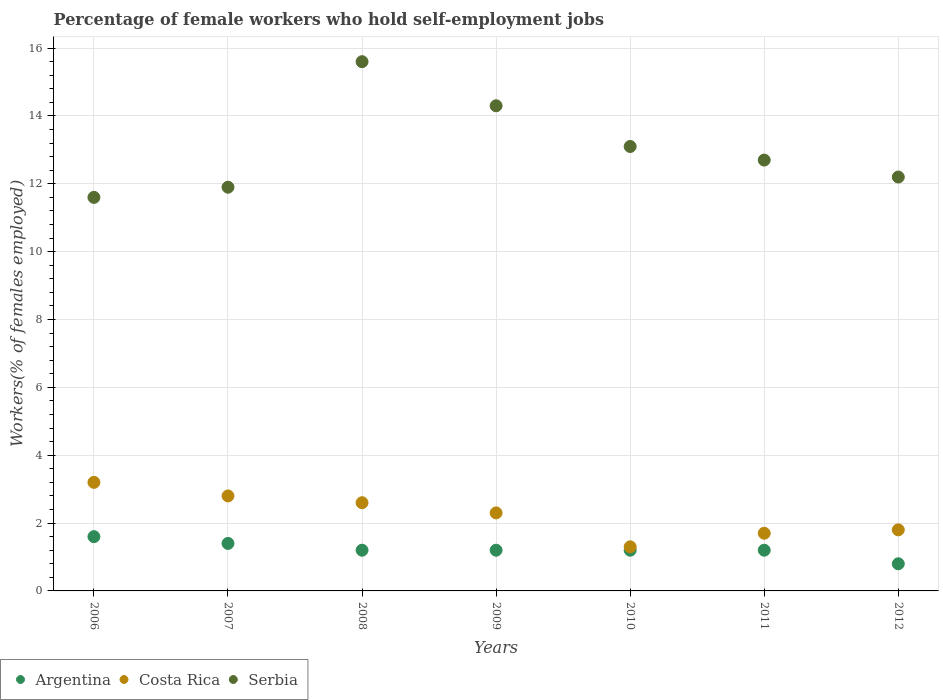What is the percentage of self-employed female workers in Argentina in 2006?
Offer a very short reply. 1.6. Across all years, what is the maximum percentage of self-employed female workers in Serbia?
Provide a short and direct response. 15.6. Across all years, what is the minimum percentage of self-employed female workers in Serbia?
Give a very brief answer. 11.6. What is the total percentage of self-employed female workers in Argentina in the graph?
Your answer should be compact. 8.6. What is the difference between the percentage of self-employed female workers in Costa Rica in 2007 and that in 2008?
Offer a terse response. 0.2. What is the difference between the percentage of self-employed female workers in Argentina in 2007 and the percentage of self-employed female workers in Costa Rica in 2012?
Give a very brief answer. -0.4. What is the average percentage of self-employed female workers in Serbia per year?
Give a very brief answer. 13.06. In the year 2011, what is the difference between the percentage of self-employed female workers in Serbia and percentage of self-employed female workers in Argentina?
Offer a very short reply. 11.5. What is the difference between the highest and the second highest percentage of self-employed female workers in Argentina?
Make the answer very short. 0.2. What is the difference between the highest and the lowest percentage of self-employed female workers in Argentina?
Provide a succinct answer. 0.8. In how many years, is the percentage of self-employed female workers in Serbia greater than the average percentage of self-employed female workers in Serbia taken over all years?
Offer a very short reply. 3. Is the sum of the percentage of self-employed female workers in Costa Rica in 2010 and 2012 greater than the maximum percentage of self-employed female workers in Argentina across all years?
Provide a short and direct response. Yes. Is it the case that in every year, the sum of the percentage of self-employed female workers in Serbia and percentage of self-employed female workers in Costa Rica  is greater than the percentage of self-employed female workers in Argentina?
Provide a short and direct response. Yes. Is the percentage of self-employed female workers in Costa Rica strictly greater than the percentage of self-employed female workers in Argentina over the years?
Your answer should be very brief. Yes. Is the percentage of self-employed female workers in Serbia strictly less than the percentage of self-employed female workers in Argentina over the years?
Your answer should be very brief. No. Does the graph contain grids?
Your response must be concise. Yes. Where does the legend appear in the graph?
Keep it short and to the point. Bottom left. How are the legend labels stacked?
Offer a very short reply. Horizontal. What is the title of the graph?
Offer a very short reply. Percentage of female workers who hold self-employment jobs. What is the label or title of the Y-axis?
Make the answer very short. Workers(% of females employed). What is the Workers(% of females employed) of Argentina in 2006?
Make the answer very short. 1.6. What is the Workers(% of females employed) in Costa Rica in 2006?
Your answer should be very brief. 3.2. What is the Workers(% of females employed) of Serbia in 2006?
Keep it short and to the point. 11.6. What is the Workers(% of females employed) in Argentina in 2007?
Provide a short and direct response. 1.4. What is the Workers(% of females employed) of Costa Rica in 2007?
Your answer should be compact. 2.8. What is the Workers(% of females employed) in Serbia in 2007?
Your answer should be very brief. 11.9. What is the Workers(% of females employed) in Argentina in 2008?
Provide a succinct answer. 1.2. What is the Workers(% of females employed) in Costa Rica in 2008?
Offer a very short reply. 2.6. What is the Workers(% of females employed) in Serbia in 2008?
Offer a terse response. 15.6. What is the Workers(% of females employed) in Argentina in 2009?
Make the answer very short. 1.2. What is the Workers(% of females employed) in Costa Rica in 2009?
Your answer should be very brief. 2.3. What is the Workers(% of females employed) in Serbia in 2009?
Provide a succinct answer. 14.3. What is the Workers(% of females employed) of Argentina in 2010?
Ensure brevity in your answer.  1.2. What is the Workers(% of females employed) in Costa Rica in 2010?
Ensure brevity in your answer.  1.3. What is the Workers(% of females employed) in Serbia in 2010?
Provide a short and direct response. 13.1. What is the Workers(% of females employed) of Argentina in 2011?
Your answer should be compact. 1.2. What is the Workers(% of females employed) of Costa Rica in 2011?
Make the answer very short. 1.7. What is the Workers(% of females employed) in Serbia in 2011?
Ensure brevity in your answer.  12.7. What is the Workers(% of females employed) of Argentina in 2012?
Provide a succinct answer. 0.8. What is the Workers(% of females employed) of Costa Rica in 2012?
Your answer should be very brief. 1.8. What is the Workers(% of females employed) of Serbia in 2012?
Ensure brevity in your answer.  12.2. Across all years, what is the maximum Workers(% of females employed) of Argentina?
Make the answer very short. 1.6. Across all years, what is the maximum Workers(% of females employed) in Costa Rica?
Your answer should be very brief. 3.2. Across all years, what is the maximum Workers(% of females employed) of Serbia?
Your answer should be compact. 15.6. Across all years, what is the minimum Workers(% of females employed) of Argentina?
Your answer should be compact. 0.8. Across all years, what is the minimum Workers(% of females employed) of Costa Rica?
Keep it short and to the point. 1.3. Across all years, what is the minimum Workers(% of females employed) in Serbia?
Keep it short and to the point. 11.6. What is the total Workers(% of females employed) in Argentina in the graph?
Offer a terse response. 8.6. What is the total Workers(% of females employed) of Costa Rica in the graph?
Your response must be concise. 15.7. What is the total Workers(% of females employed) in Serbia in the graph?
Your response must be concise. 91.4. What is the difference between the Workers(% of females employed) in Argentina in 2006 and that in 2007?
Keep it short and to the point. 0.2. What is the difference between the Workers(% of females employed) in Costa Rica in 2006 and that in 2008?
Provide a succinct answer. 0.6. What is the difference between the Workers(% of females employed) in Argentina in 2006 and that in 2009?
Ensure brevity in your answer.  0.4. What is the difference between the Workers(% of females employed) in Costa Rica in 2006 and that in 2009?
Your response must be concise. 0.9. What is the difference between the Workers(% of females employed) in Argentina in 2006 and that in 2010?
Your answer should be very brief. 0.4. What is the difference between the Workers(% of females employed) of Serbia in 2006 and that in 2010?
Give a very brief answer. -1.5. What is the difference between the Workers(% of females employed) in Costa Rica in 2006 and that in 2011?
Provide a succinct answer. 1.5. What is the difference between the Workers(% of females employed) of Costa Rica in 2006 and that in 2012?
Your answer should be very brief. 1.4. What is the difference between the Workers(% of females employed) in Costa Rica in 2007 and that in 2008?
Make the answer very short. 0.2. What is the difference between the Workers(% of females employed) of Costa Rica in 2007 and that in 2009?
Ensure brevity in your answer.  0.5. What is the difference between the Workers(% of females employed) in Serbia in 2007 and that in 2009?
Offer a terse response. -2.4. What is the difference between the Workers(% of females employed) in Argentina in 2007 and that in 2010?
Your response must be concise. 0.2. What is the difference between the Workers(% of females employed) of Serbia in 2007 and that in 2010?
Ensure brevity in your answer.  -1.2. What is the difference between the Workers(% of females employed) of Argentina in 2007 and that in 2011?
Make the answer very short. 0.2. What is the difference between the Workers(% of females employed) of Serbia in 2007 and that in 2011?
Your answer should be very brief. -0.8. What is the difference between the Workers(% of females employed) of Costa Rica in 2007 and that in 2012?
Provide a short and direct response. 1. What is the difference between the Workers(% of females employed) in Serbia in 2007 and that in 2012?
Your answer should be very brief. -0.3. What is the difference between the Workers(% of females employed) of Costa Rica in 2008 and that in 2009?
Ensure brevity in your answer.  0.3. What is the difference between the Workers(% of females employed) in Serbia in 2008 and that in 2010?
Your response must be concise. 2.5. What is the difference between the Workers(% of females employed) of Argentina in 2008 and that in 2011?
Give a very brief answer. 0. What is the difference between the Workers(% of females employed) in Serbia in 2008 and that in 2011?
Give a very brief answer. 2.9. What is the difference between the Workers(% of females employed) in Argentina in 2008 and that in 2012?
Provide a succinct answer. 0.4. What is the difference between the Workers(% of females employed) in Costa Rica in 2008 and that in 2012?
Give a very brief answer. 0.8. What is the difference between the Workers(% of females employed) in Serbia in 2008 and that in 2012?
Your response must be concise. 3.4. What is the difference between the Workers(% of females employed) of Argentina in 2009 and that in 2010?
Offer a terse response. 0. What is the difference between the Workers(% of females employed) of Costa Rica in 2009 and that in 2010?
Make the answer very short. 1. What is the difference between the Workers(% of females employed) in Serbia in 2009 and that in 2010?
Offer a very short reply. 1.2. What is the difference between the Workers(% of females employed) of Argentina in 2009 and that in 2011?
Provide a short and direct response. 0. What is the difference between the Workers(% of females employed) in Serbia in 2009 and that in 2011?
Your response must be concise. 1.6. What is the difference between the Workers(% of females employed) in Argentina in 2009 and that in 2012?
Provide a succinct answer. 0.4. What is the difference between the Workers(% of females employed) in Serbia in 2010 and that in 2012?
Provide a succinct answer. 0.9. What is the difference between the Workers(% of females employed) of Costa Rica in 2011 and that in 2012?
Ensure brevity in your answer.  -0.1. What is the difference between the Workers(% of females employed) of Serbia in 2011 and that in 2012?
Provide a succinct answer. 0.5. What is the difference between the Workers(% of females employed) of Argentina in 2006 and the Workers(% of females employed) of Serbia in 2007?
Offer a terse response. -10.3. What is the difference between the Workers(% of females employed) of Argentina in 2006 and the Workers(% of females employed) of Serbia in 2008?
Ensure brevity in your answer.  -14. What is the difference between the Workers(% of females employed) in Costa Rica in 2006 and the Workers(% of females employed) in Serbia in 2008?
Give a very brief answer. -12.4. What is the difference between the Workers(% of females employed) in Argentina in 2006 and the Workers(% of females employed) in Serbia in 2010?
Provide a short and direct response. -11.5. What is the difference between the Workers(% of females employed) in Argentina in 2006 and the Workers(% of females employed) in Serbia in 2011?
Provide a succinct answer. -11.1. What is the difference between the Workers(% of females employed) of Argentina in 2006 and the Workers(% of females employed) of Serbia in 2012?
Make the answer very short. -10.6. What is the difference between the Workers(% of females employed) of Costa Rica in 2006 and the Workers(% of females employed) of Serbia in 2012?
Give a very brief answer. -9. What is the difference between the Workers(% of females employed) of Argentina in 2007 and the Workers(% of females employed) of Costa Rica in 2008?
Provide a succinct answer. -1.2. What is the difference between the Workers(% of females employed) in Argentina in 2007 and the Workers(% of females employed) in Serbia in 2008?
Offer a very short reply. -14.2. What is the difference between the Workers(% of females employed) in Costa Rica in 2007 and the Workers(% of females employed) in Serbia in 2008?
Your answer should be very brief. -12.8. What is the difference between the Workers(% of females employed) of Argentina in 2007 and the Workers(% of females employed) of Serbia in 2009?
Keep it short and to the point. -12.9. What is the difference between the Workers(% of females employed) of Costa Rica in 2007 and the Workers(% of females employed) of Serbia in 2009?
Offer a very short reply. -11.5. What is the difference between the Workers(% of females employed) of Argentina in 2007 and the Workers(% of females employed) of Serbia in 2010?
Make the answer very short. -11.7. What is the difference between the Workers(% of females employed) in Argentina in 2007 and the Workers(% of females employed) in Costa Rica in 2011?
Keep it short and to the point. -0.3. What is the difference between the Workers(% of females employed) in Costa Rica in 2007 and the Workers(% of females employed) in Serbia in 2011?
Offer a terse response. -9.9. What is the difference between the Workers(% of females employed) in Argentina in 2007 and the Workers(% of females employed) in Costa Rica in 2012?
Your answer should be compact. -0.4. What is the difference between the Workers(% of females employed) of Costa Rica in 2007 and the Workers(% of females employed) of Serbia in 2012?
Provide a short and direct response. -9.4. What is the difference between the Workers(% of females employed) in Argentina in 2008 and the Workers(% of females employed) in Costa Rica in 2011?
Provide a short and direct response. -0.5. What is the difference between the Workers(% of females employed) of Costa Rica in 2008 and the Workers(% of females employed) of Serbia in 2011?
Offer a very short reply. -10.1. What is the difference between the Workers(% of females employed) in Argentina in 2009 and the Workers(% of females employed) in Costa Rica in 2010?
Provide a short and direct response. -0.1. What is the difference between the Workers(% of females employed) in Argentina in 2009 and the Workers(% of females employed) in Serbia in 2010?
Offer a terse response. -11.9. What is the difference between the Workers(% of females employed) of Costa Rica in 2009 and the Workers(% of females employed) of Serbia in 2010?
Your response must be concise. -10.8. What is the difference between the Workers(% of females employed) in Argentina in 2009 and the Workers(% of females employed) in Costa Rica in 2011?
Your answer should be compact. -0.5. What is the difference between the Workers(% of females employed) of Costa Rica in 2009 and the Workers(% of females employed) of Serbia in 2011?
Keep it short and to the point. -10.4. What is the difference between the Workers(% of females employed) of Argentina in 2010 and the Workers(% of females employed) of Costa Rica in 2012?
Your answer should be very brief. -0.6. What is the difference between the Workers(% of females employed) of Argentina in 2010 and the Workers(% of females employed) of Serbia in 2012?
Your answer should be very brief. -11. What is the difference between the Workers(% of females employed) of Argentina in 2011 and the Workers(% of females employed) of Costa Rica in 2012?
Offer a terse response. -0.6. What is the difference between the Workers(% of females employed) of Costa Rica in 2011 and the Workers(% of females employed) of Serbia in 2012?
Provide a short and direct response. -10.5. What is the average Workers(% of females employed) in Argentina per year?
Keep it short and to the point. 1.23. What is the average Workers(% of females employed) of Costa Rica per year?
Keep it short and to the point. 2.24. What is the average Workers(% of females employed) in Serbia per year?
Offer a very short reply. 13.06. In the year 2006, what is the difference between the Workers(% of females employed) of Argentina and Workers(% of females employed) of Costa Rica?
Your answer should be compact. -1.6. In the year 2006, what is the difference between the Workers(% of females employed) in Costa Rica and Workers(% of females employed) in Serbia?
Offer a very short reply. -8.4. In the year 2007, what is the difference between the Workers(% of females employed) of Argentina and Workers(% of females employed) of Serbia?
Your response must be concise. -10.5. In the year 2008, what is the difference between the Workers(% of females employed) in Argentina and Workers(% of females employed) in Costa Rica?
Offer a terse response. -1.4. In the year 2008, what is the difference between the Workers(% of females employed) of Argentina and Workers(% of females employed) of Serbia?
Give a very brief answer. -14.4. In the year 2011, what is the difference between the Workers(% of females employed) in Argentina and Workers(% of females employed) in Serbia?
Keep it short and to the point. -11.5. In the year 2011, what is the difference between the Workers(% of females employed) in Costa Rica and Workers(% of females employed) in Serbia?
Your response must be concise. -11. In the year 2012, what is the difference between the Workers(% of females employed) of Costa Rica and Workers(% of females employed) of Serbia?
Provide a short and direct response. -10.4. What is the ratio of the Workers(% of females employed) in Argentina in 2006 to that in 2007?
Offer a terse response. 1.14. What is the ratio of the Workers(% of females employed) of Costa Rica in 2006 to that in 2007?
Ensure brevity in your answer.  1.14. What is the ratio of the Workers(% of females employed) of Serbia in 2006 to that in 2007?
Ensure brevity in your answer.  0.97. What is the ratio of the Workers(% of females employed) in Costa Rica in 2006 to that in 2008?
Provide a succinct answer. 1.23. What is the ratio of the Workers(% of females employed) of Serbia in 2006 to that in 2008?
Your answer should be compact. 0.74. What is the ratio of the Workers(% of females employed) of Argentina in 2006 to that in 2009?
Keep it short and to the point. 1.33. What is the ratio of the Workers(% of females employed) of Costa Rica in 2006 to that in 2009?
Your answer should be very brief. 1.39. What is the ratio of the Workers(% of females employed) in Serbia in 2006 to that in 2009?
Offer a very short reply. 0.81. What is the ratio of the Workers(% of females employed) of Costa Rica in 2006 to that in 2010?
Provide a short and direct response. 2.46. What is the ratio of the Workers(% of females employed) in Serbia in 2006 to that in 2010?
Offer a very short reply. 0.89. What is the ratio of the Workers(% of females employed) in Argentina in 2006 to that in 2011?
Provide a short and direct response. 1.33. What is the ratio of the Workers(% of females employed) in Costa Rica in 2006 to that in 2011?
Your answer should be very brief. 1.88. What is the ratio of the Workers(% of females employed) in Serbia in 2006 to that in 2011?
Provide a short and direct response. 0.91. What is the ratio of the Workers(% of females employed) of Argentina in 2006 to that in 2012?
Provide a succinct answer. 2. What is the ratio of the Workers(% of females employed) in Costa Rica in 2006 to that in 2012?
Offer a terse response. 1.78. What is the ratio of the Workers(% of females employed) of Serbia in 2006 to that in 2012?
Your response must be concise. 0.95. What is the ratio of the Workers(% of females employed) in Argentina in 2007 to that in 2008?
Give a very brief answer. 1.17. What is the ratio of the Workers(% of females employed) in Serbia in 2007 to that in 2008?
Provide a succinct answer. 0.76. What is the ratio of the Workers(% of females employed) of Argentina in 2007 to that in 2009?
Offer a very short reply. 1.17. What is the ratio of the Workers(% of females employed) of Costa Rica in 2007 to that in 2009?
Your response must be concise. 1.22. What is the ratio of the Workers(% of females employed) of Serbia in 2007 to that in 2009?
Make the answer very short. 0.83. What is the ratio of the Workers(% of females employed) in Costa Rica in 2007 to that in 2010?
Offer a terse response. 2.15. What is the ratio of the Workers(% of females employed) in Serbia in 2007 to that in 2010?
Offer a very short reply. 0.91. What is the ratio of the Workers(% of females employed) in Costa Rica in 2007 to that in 2011?
Offer a terse response. 1.65. What is the ratio of the Workers(% of females employed) of Serbia in 2007 to that in 2011?
Your answer should be compact. 0.94. What is the ratio of the Workers(% of females employed) of Argentina in 2007 to that in 2012?
Offer a terse response. 1.75. What is the ratio of the Workers(% of females employed) in Costa Rica in 2007 to that in 2012?
Keep it short and to the point. 1.56. What is the ratio of the Workers(% of females employed) in Serbia in 2007 to that in 2012?
Keep it short and to the point. 0.98. What is the ratio of the Workers(% of females employed) in Costa Rica in 2008 to that in 2009?
Your response must be concise. 1.13. What is the ratio of the Workers(% of females employed) in Serbia in 2008 to that in 2009?
Your answer should be very brief. 1.09. What is the ratio of the Workers(% of females employed) in Argentina in 2008 to that in 2010?
Your response must be concise. 1. What is the ratio of the Workers(% of females employed) in Serbia in 2008 to that in 2010?
Ensure brevity in your answer.  1.19. What is the ratio of the Workers(% of females employed) of Costa Rica in 2008 to that in 2011?
Your answer should be very brief. 1.53. What is the ratio of the Workers(% of females employed) of Serbia in 2008 to that in 2011?
Offer a very short reply. 1.23. What is the ratio of the Workers(% of females employed) of Costa Rica in 2008 to that in 2012?
Offer a very short reply. 1.44. What is the ratio of the Workers(% of females employed) in Serbia in 2008 to that in 2012?
Offer a very short reply. 1.28. What is the ratio of the Workers(% of females employed) in Argentina in 2009 to that in 2010?
Your answer should be very brief. 1. What is the ratio of the Workers(% of females employed) in Costa Rica in 2009 to that in 2010?
Your answer should be very brief. 1.77. What is the ratio of the Workers(% of females employed) in Serbia in 2009 to that in 2010?
Provide a succinct answer. 1.09. What is the ratio of the Workers(% of females employed) of Argentina in 2009 to that in 2011?
Ensure brevity in your answer.  1. What is the ratio of the Workers(% of females employed) of Costa Rica in 2009 to that in 2011?
Offer a terse response. 1.35. What is the ratio of the Workers(% of females employed) in Serbia in 2009 to that in 2011?
Your answer should be very brief. 1.13. What is the ratio of the Workers(% of females employed) of Argentina in 2009 to that in 2012?
Offer a very short reply. 1.5. What is the ratio of the Workers(% of females employed) in Costa Rica in 2009 to that in 2012?
Offer a terse response. 1.28. What is the ratio of the Workers(% of females employed) of Serbia in 2009 to that in 2012?
Make the answer very short. 1.17. What is the ratio of the Workers(% of females employed) of Argentina in 2010 to that in 2011?
Provide a short and direct response. 1. What is the ratio of the Workers(% of females employed) of Costa Rica in 2010 to that in 2011?
Offer a very short reply. 0.76. What is the ratio of the Workers(% of females employed) of Serbia in 2010 to that in 2011?
Ensure brevity in your answer.  1.03. What is the ratio of the Workers(% of females employed) of Costa Rica in 2010 to that in 2012?
Your response must be concise. 0.72. What is the ratio of the Workers(% of females employed) of Serbia in 2010 to that in 2012?
Give a very brief answer. 1.07. What is the ratio of the Workers(% of females employed) of Serbia in 2011 to that in 2012?
Provide a succinct answer. 1.04. What is the difference between the highest and the second highest Workers(% of females employed) of Argentina?
Provide a succinct answer. 0.2. What is the difference between the highest and the second highest Workers(% of females employed) of Costa Rica?
Provide a succinct answer. 0.4. What is the difference between the highest and the second highest Workers(% of females employed) in Serbia?
Ensure brevity in your answer.  1.3. What is the difference between the highest and the lowest Workers(% of females employed) in Argentina?
Your answer should be very brief. 0.8. What is the difference between the highest and the lowest Workers(% of females employed) in Costa Rica?
Keep it short and to the point. 1.9. What is the difference between the highest and the lowest Workers(% of females employed) of Serbia?
Keep it short and to the point. 4. 